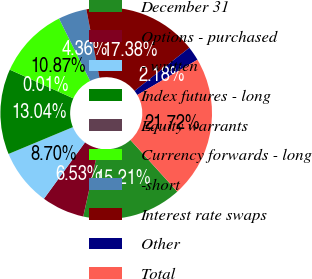Convert chart. <chart><loc_0><loc_0><loc_500><loc_500><pie_chart><fcel>December 31<fcel>Options - purchased<fcel>- written<fcel>Index futures - long<fcel>Equity warrants<fcel>Currency forwards - long<fcel>-short<fcel>Interest rate swaps<fcel>Other<fcel>Total<nl><fcel>15.21%<fcel>6.53%<fcel>8.7%<fcel>13.04%<fcel>0.01%<fcel>10.87%<fcel>4.36%<fcel>17.38%<fcel>2.18%<fcel>21.72%<nl></chart> 